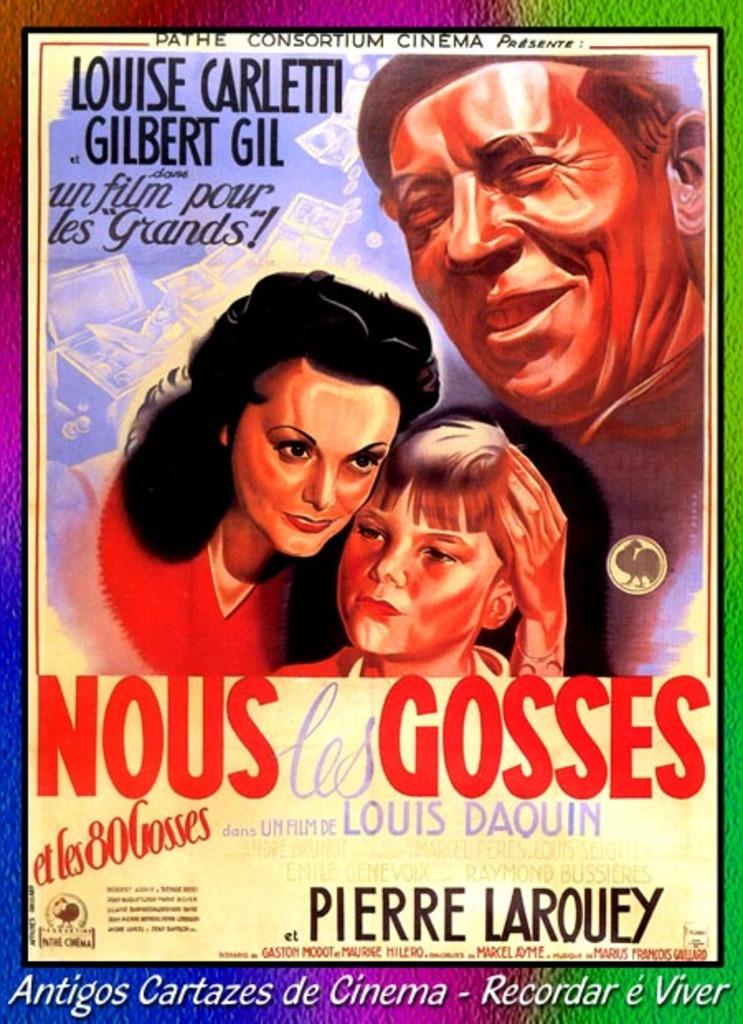<image>
Relay a brief, clear account of the picture shown. A poster for Nous les Gosses, starring Louise Carletti. 